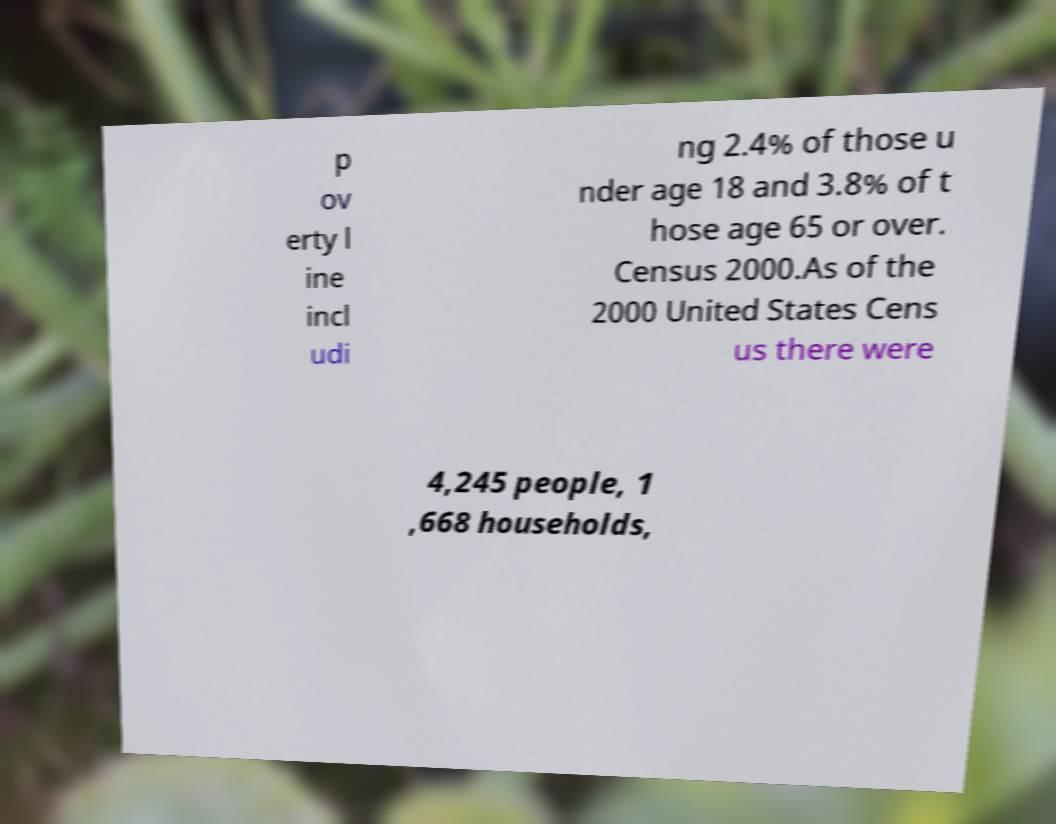What messages or text are displayed in this image? I need them in a readable, typed format. p ov erty l ine incl udi ng 2.4% of those u nder age 18 and 3.8% of t hose age 65 or over. Census 2000.As of the 2000 United States Cens us there were 4,245 people, 1 ,668 households, 